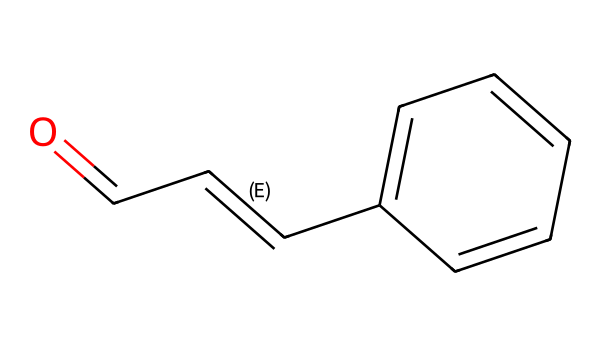What is the functional group present in cinnamaldehyde? The structure shows the carbonyl group (C=O) at the beginning of the molecule, which indicates it is an aldehyde.
Answer: aldehyde How many carbon atoms are in cinnamaldehyde? By examining the SMILES representation, there are a total of 9 carbon atoms in cinnamaldehyde's structure.
Answer: 9 What type of double bond is present in the structure of cinnamaldehyde? The SMILES notation indicates a carbon-carbon double bond between the second and third carbon atoms and a carbon-oxygen double bond indicating the presence of an aldehyde carbonyl.
Answer: carbon-carbon Which atom is involved in the functional group of cinnamaldehyde? The carbon atom in the carbonyl group (C=O) is key to defining it as an aldehyde; it distinguishes it from other organic compounds.
Answer: carbon What is the molecular formula of cinnamaldehyde? By analyzing the count of each atom from the SMILES structure, we derive that the molecular formula of cinnamaldehyde is C9H8O.
Answer: C9H8O Does the structure of cinnamaldehyde suggest it has aromatic properties? Yes, the presence of a benzene ring in the structure (noted as 'c1ccccc1') indicates that it has aromatic properties, typical of compounds with a planar, cyclic structure with delocalized pi electrons.
Answer: yes What indicates that cinnamaldehyde is an unsaturated compound? The presence of double bonds (both C=C and C=O) within the structure signifies that this compound is unsaturated, meaning it has fewer hydrogen atoms than the maximum possible for saturated compounds.
Answer: double bonds 